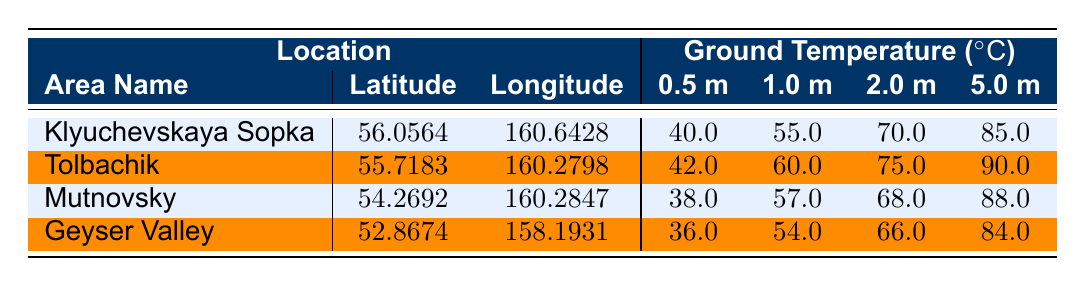What is the ground temperature at a depth of 2.0 meters in Klyuchevskaya Sopka? The table shows that at a depth of 2.0 meters, the temperature for Klyuchevskaya Sopka is recorded as 70.0 degrees Celsius.
Answer: 70.0 Which geothermal area has the highest ground temperature at 5.0 meters? By comparing the 5.0 meter temperatures across the areas, Tolbachik has the highest temperature of 90.0 degrees Celsius.
Answer: Tolbachik What is the average ground temperature at 1.0 meter depth across all areas? To find the average, we sum the 1.0 meter temperatures: 55.0 (Klyuchevskaya Sopka) + 60.0 (Tolbachik) + 57.0 (Mutnovsky) + 54.0 (Geyser Valley) = 226.0. There are 4 areas, so the average is 226.0 / 4 = 56.5.
Answer: 56.5 Is the ground temperature at a depth of 0.5 meters higher in Mutnovsky than in Geyser Valley? At 0.5 meters, Mutnovsky has a temperature of 38.0 degrees Celsius, while Geyser Valley has 36.0 degrees Celsius. This means Mutnovsky's temperature is higher than Geyser Valley's.
Answer: Yes What is the difference in ground temperature at a depth of 2.0 meters between Klyuchevskaya Sopka and Geyser Valley? Klyuchevskaya Sopka's temperature at 2.0 meters is 70.0 degrees Celsius and Geyser Valley's is 66.0 degrees Celsius. The difference is 70.0 - 66.0 = 4.0 degrees Celsius.
Answer: 4.0 Which area has the lowest temperature at 0.5 meters? Looking at the table, Geyser Valley has the lowest temperature at 0.5 meters with a value of 36.0 degrees Celsius.
Answer: Geyser Valley Are the ground temperatures at 5.0 meters higher in Mutnovsky than Tolbachik? The temperatures at 5.0 meters are 88.0 degrees Celsius for Mutnovsky and 90.0 degrees Celsius for Tolbachik. Since 88.0 is less than 90.0, Mutnovsky's is lower.
Answer: No What is the ground temperature trend as depth increases for the Klyuchevskaya Sopka area? Analyzing the values in the table: the temperatures at different depths (0.5 m = 40.0, 1.0 m = 55.0, 2.0 m = 70.0, 5.0 m = 85.0) show an increasing trend. Therefore, the temperatures rise as depth increases.
Answer: Increasing trend 